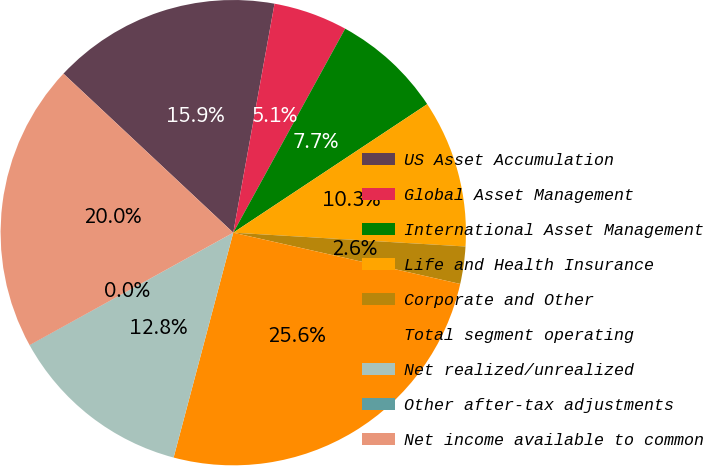Convert chart to OTSL. <chart><loc_0><loc_0><loc_500><loc_500><pie_chart><fcel>US Asset Accumulation<fcel>Global Asset Management<fcel>International Asset Management<fcel>Life and Health Insurance<fcel>Corporate and Other<fcel>Total segment operating<fcel>Net realized/unrealized<fcel>Other after-tax adjustments<fcel>Net income available to common<nl><fcel>15.86%<fcel>5.15%<fcel>7.7%<fcel>10.26%<fcel>2.59%<fcel>25.59%<fcel>12.81%<fcel>0.03%<fcel>20.01%<nl></chart> 